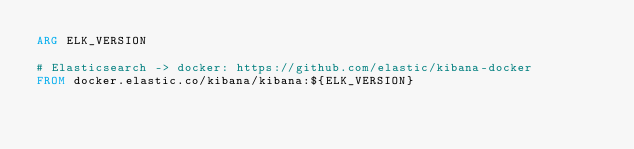<code> <loc_0><loc_0><loc_500><loc_500><_Dockerfile_>ARG ELK_VERSION

# Elasticsearch -> docker: https://github.com/elastic/kibana-docker
FROM docker.elastic.co/kibana/kibana:${ELK_VERSION}
</code> 